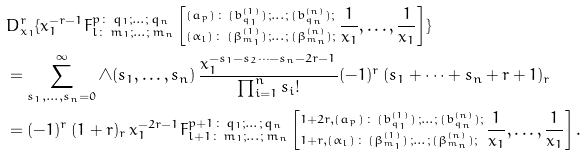<formula> <loc_0><loc_0><loc_500><loc_500>& D _ { x _ { 1 } } ^ { r } \{ x _ { 1 } ^ { - r - 1 } F _ { { l } \colon \, m _ { 1 } ; \dots ; \, m _ { n } } ^ { p \colon \, q _ { 1 } ; \dots ; \, q _ { n } } \left [ ^ { ( a _ { p } ) \, \colon \, ( b ^ { ( 1 ) } _ { q _ { 1 } } ) \, ; \dots ; \, ( b ^ { ( n ) } _ { q _ { n } } ) ; } _ { ( \alpha _ { l } ) \, \colon \, ( \beta ^ { ( 1 ) } _ { m _ { 1 } } ) \, ; \dots ; \, ( \beta ^ { ( n ) } _ { m _ { n } } ) ; } \, \frac { 1 } { x _ { 1 } } , \dots , \frac { 1 } { x _ { 1 } } \right ] \} \\ & = \sum _ { s _ { 1 } , \dots , s _ { n } = 0 } ^ { \infty } \wedge ( s _ { 1 } , \dots , s _ { n } ) \, \frac { x _ { 1 } ^ { - s _ { 1 } - s _ { 2 } \cdots - s _ { n } - 2 r - 1 } } { \prod _ { i = 1 } ^ { n } s _ { i } ! } ( - 1 ) ^ { r } \, ( s _ { 1 } + \cdots + s _ { n } + r + 1 ) _ { r } \\ & = ( - 1 ) ^ { r } \, ( 1 + r ) _ { r } \, x _ { 1 } ^ { - 2 r - 1 } F _ { { l + 1 } \colon \, m _ { 1 } ; \dots ; \, m _ { n } } ^ { p + 1 \colon \, q _ { 1 } ; \dots ; \, q _ { n } } \left [ ^ { 1 + 2 r , ( a _ { p } ) \, \colon \, ( b ^ { ( 1 ) } _ { q _ { 1 } } ) \, ; \dots ; \, ( b ^ { ( n ) } _ { q _ { n } } ) ; } _ { 1 + r , ( \alpha _ { l } ) \, \colon \, ( \beta ^ { ( 1 ) } _ { m _ { 1 } } ) \, ; \dots ; \, ( \beta ^ { ( n ) } _ { m _ { n } } ) ; } \, \frac { 1 } { x _ { 1 } } , \dots , \frac { 1 } { x _ { 1 } } \right ] .</formula> 